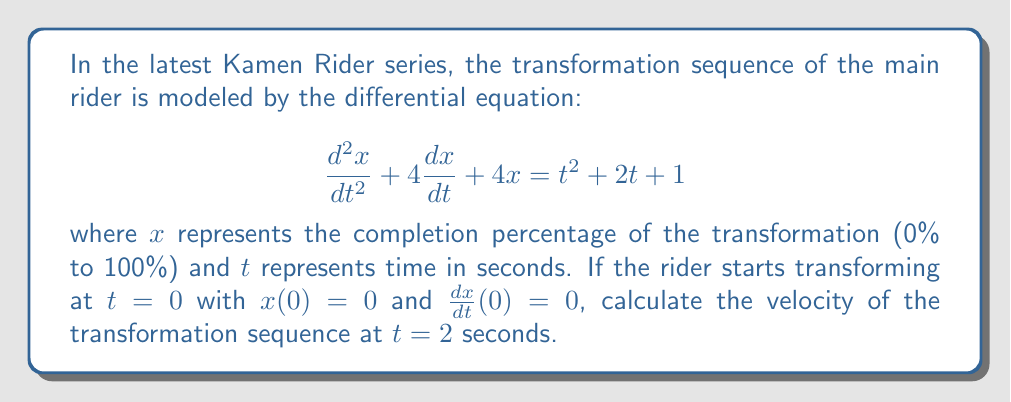Help me with this question. To solve this problem, we need to follow these steps:

1) First, we need to find the general solution to the differential equation. The left side of the equation is a second-order linear differential equation with constant coefficients, and the right side is a non-homogeneous term.

2) The characteristic equation is $r^2 + 4r + 4 = 0$, which has a repeated root $r = -2$. Therefore, the homogeneous solution is:

   $$x_h = (c_1 + c_2t)e^{-2t}$$

3) For the particular solution, we can use the method of undetermined coefficients. Let's assume a particular solution of the form:

   $$x_p = At^2 + Bt + C$$

4) Substituting this into the original equation and equating coefficients, we get:

   $$A = \frac{1}{4}, B = \frac{1}{2}, C = \frac{3}{4}$$

5) Therefore, the general solution is:

   $$x = (c_1 + c_2t)e^{-2t} + \frac{1}{4}t^2 + \frac{1}{2}t + \frac{3}{4}$$

6) Using the initial conditions $x(0)=0$ and $\frac{dx}{dt}(0)=0$, we can find $c_1$ and $c_2$:

   $$c_1 = -\frac{3}{4}, c_2 = \frac{1}{2}$$

7) So, the particular solution that satisfies the initial conditions is:

   $$x = (-\frac{3}{4} + \frac{1}{2}t)e^{-2t} + \frac{1}{4}t^2 + \frac{1}{2}t + \frac{3}{4}$$

8) To find the velocity at $t=2$, we need to differentiate this equation with respect to $t$:

   $$\frac{dx}{dt} = (\frac{1}{2} - t)e^{-2t} + \frac{1}{2}t + \frac{1}{2}$$

9) Evaluating this at $t=2$:

   $$\frac{dx}{dt}(2) = (\frac{1}{2} - 2)e^{-4} + \frac{1}{2}(2) + \frac{1}{2} = -\frac{3}{2}e^{-4} + \frac{3}{2}$$
Answer: The velocity of the transformation sequence at $t=2$ seconds is $-\frac{3}{2}e^{-4} + \frac{3}{2}$ or approximately $1.4099$ units per second. 